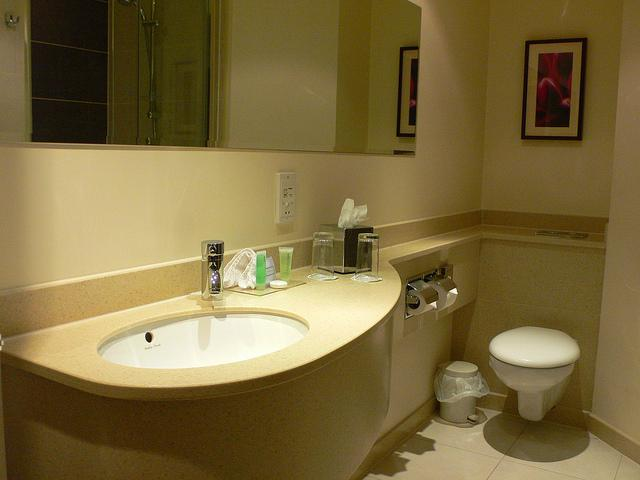What is missing from this picture? Please explain your reasoning. brush. The other items are all in the picture 